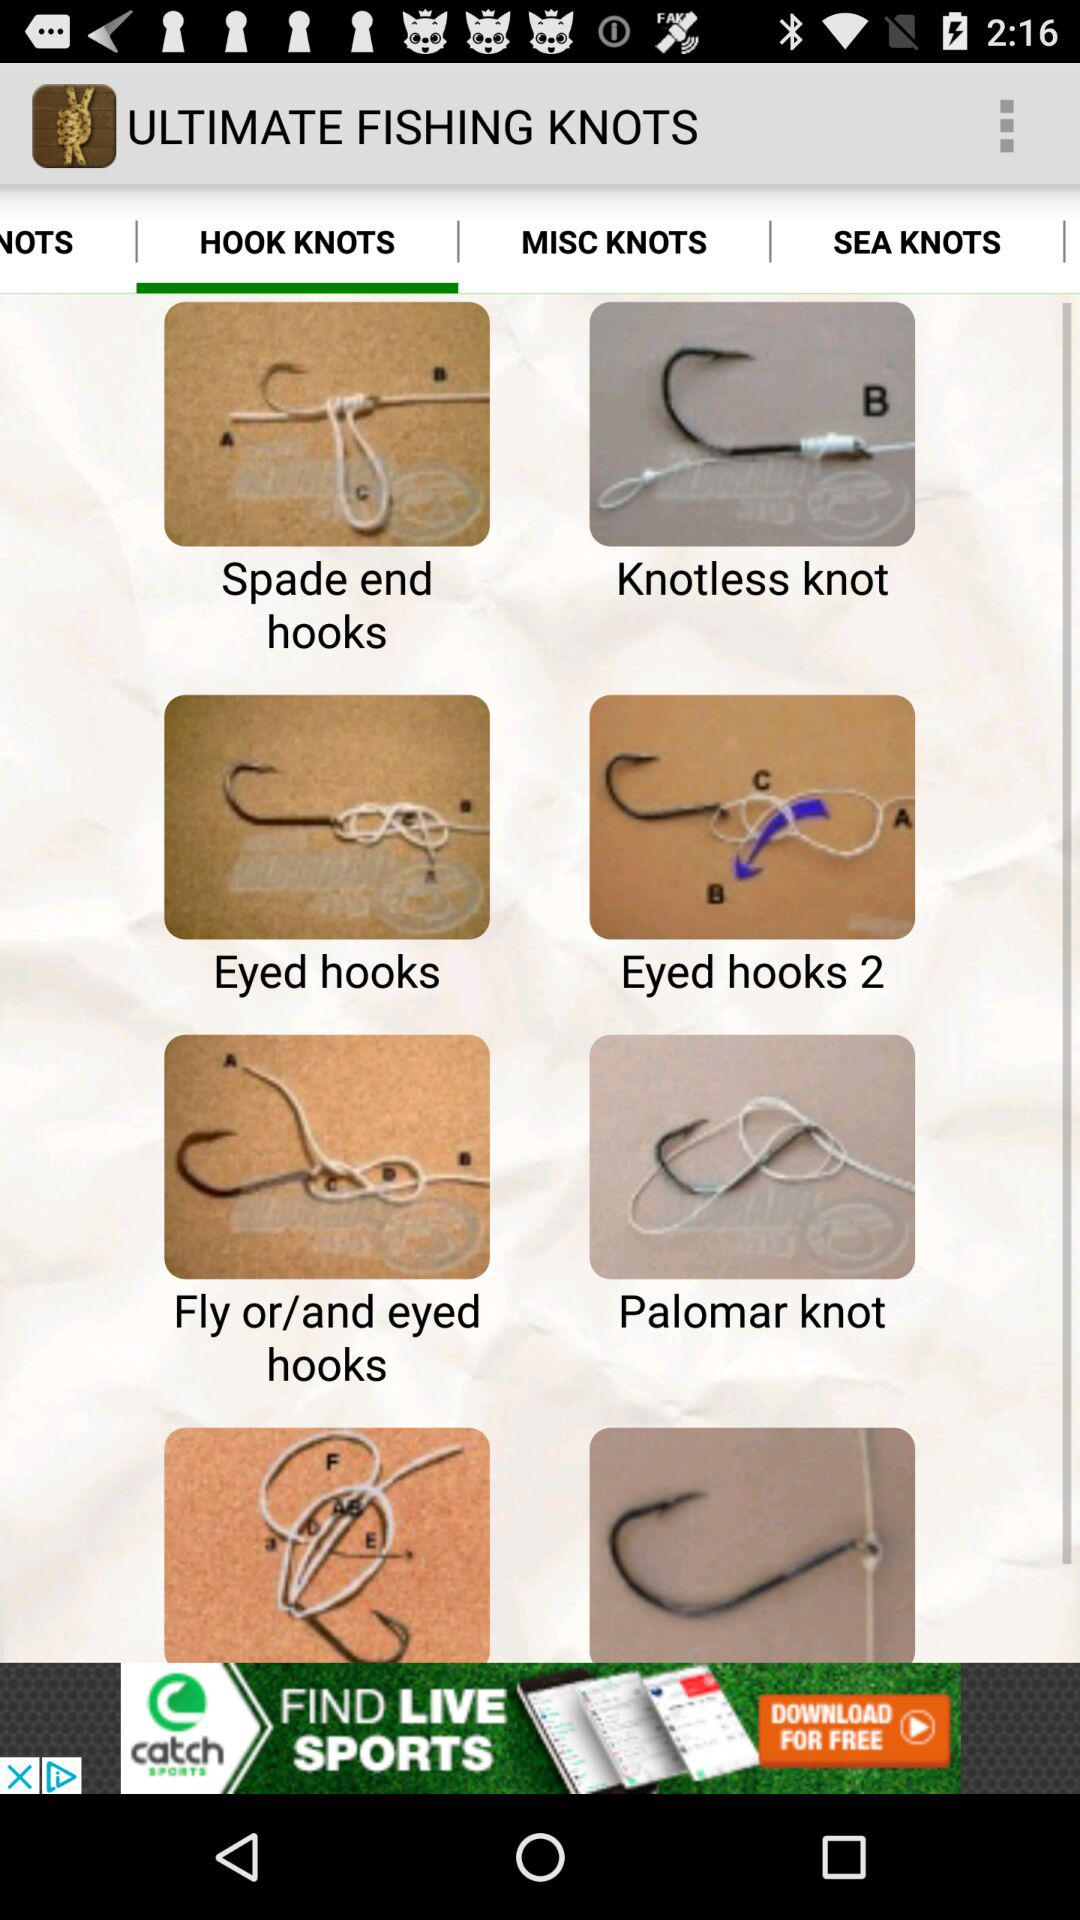What is the selected tab? The selected tab is "HOOK KNOTS". 